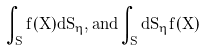Convert formula to latex. <formula><loc_0><loc_0><loc_500><loc_500>\int _ { S } f ( X ) d S _ { \eta } , a n d \int _ { S } d S _ { \eta } f ( X )</formula> 